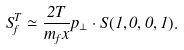Convert formula to latex. <formula><loc_0><loc_0><loc_500><loc_500>S ^ { T } _ { f } \simeq \frac { 2 T } { m _ { f } x } { p _ { \perp } } \cdot { S } ( 1 , 0 , 0 , 1 ) .</formula> 